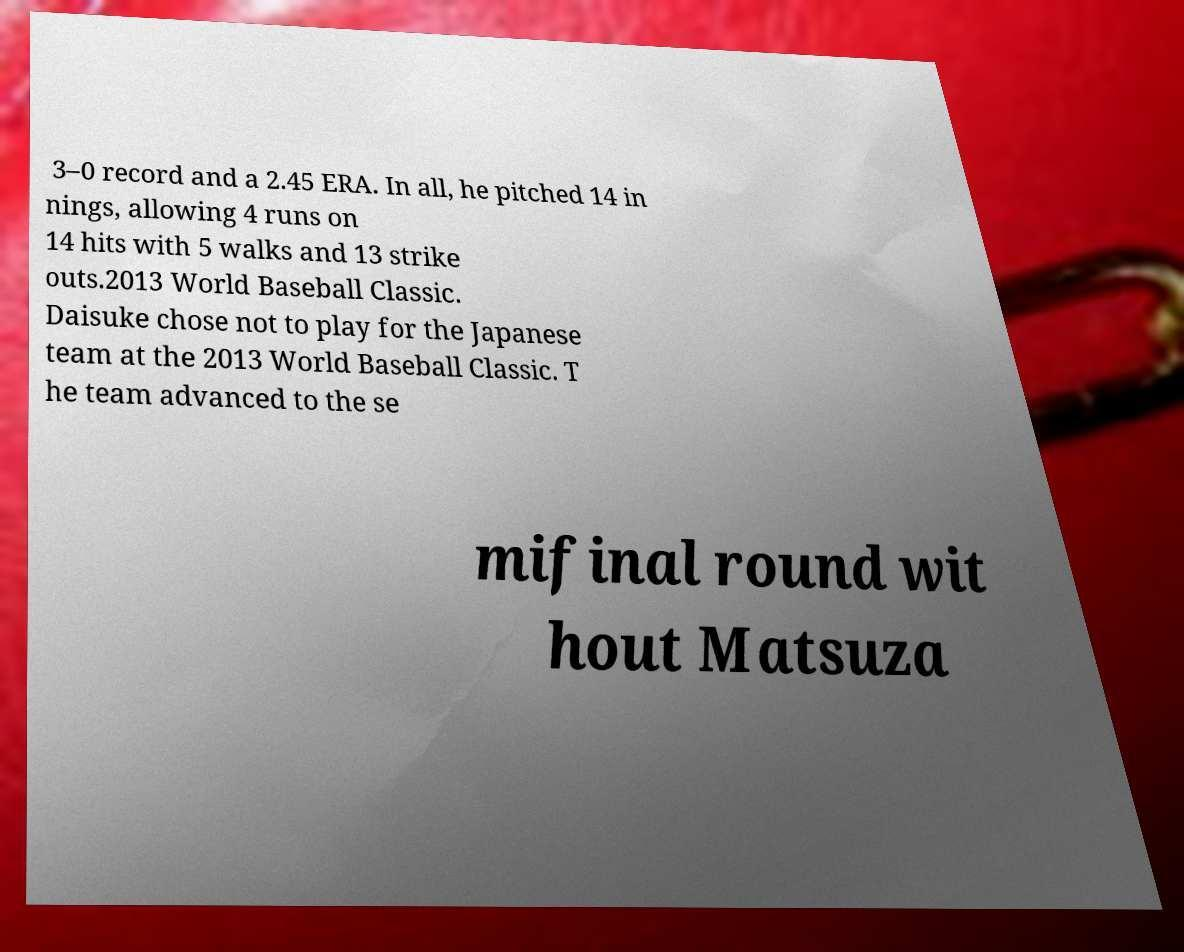Could you assist in decoding the text presented in this image and type it out clearly? 3–0 record and a 2.45 ERA. In all, he pitched 14 in nings, allowing 4 runs on 14 hits with 5 walks and 13 strike outs.2013 World Baseball Classic. Daisuke chose not to play for the Japanese team at the 2013 World Baseball Classic. T he team advanced to the se mifinal round wit hout Matsuza 